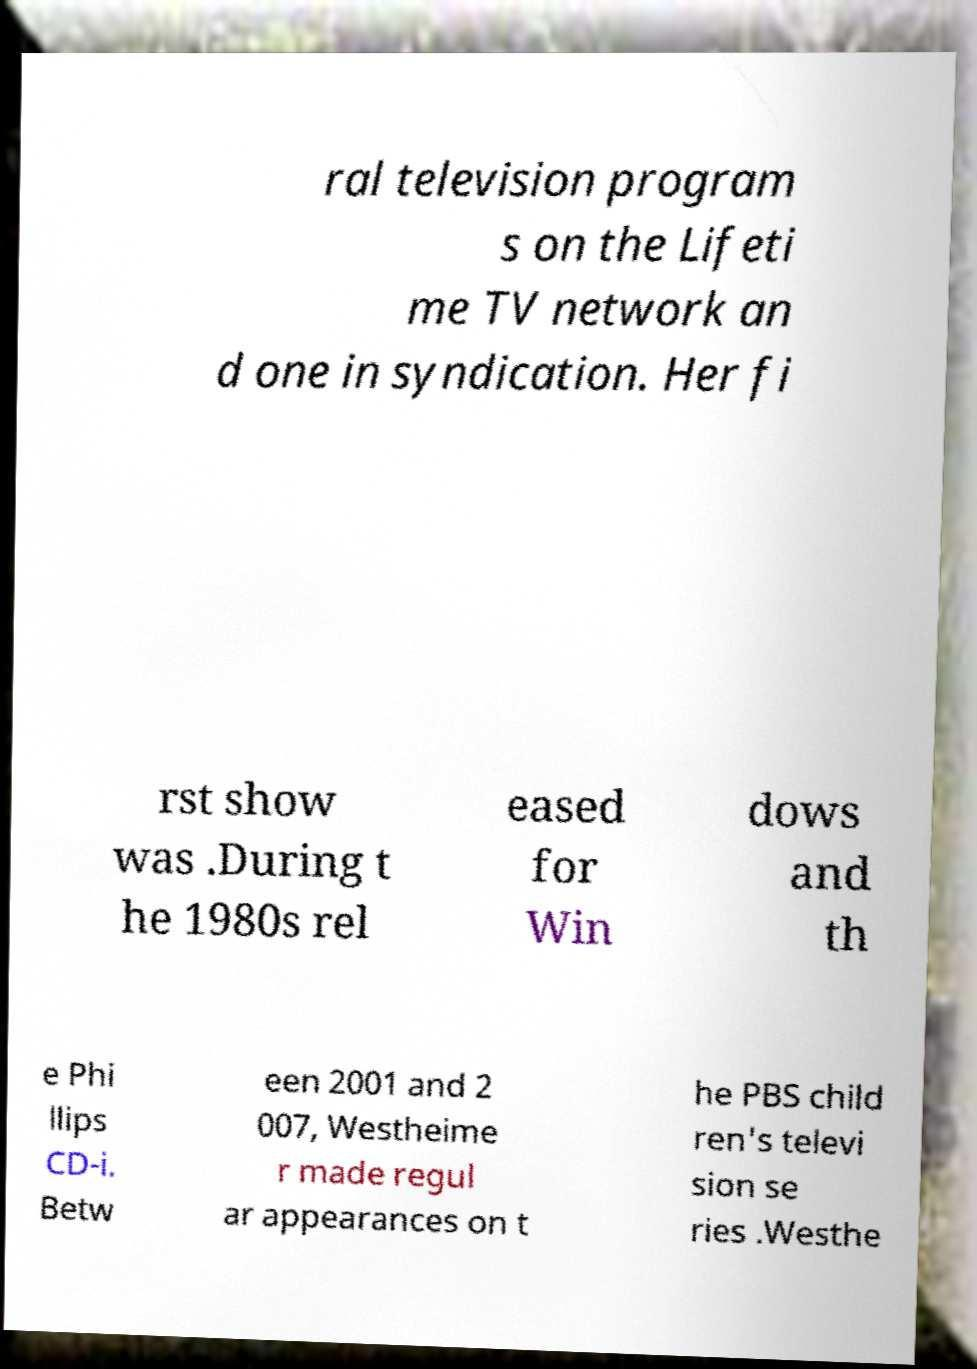What messages or text are displayed in this image? I need them in a readable, typed format. ral television program s on the Lifeti me TV network an d one in syndication. Her fi rst show was .During t he 1980s rel eased for Win dows and th e Phi llips CD-i. Betw een 2001 and 2 007, Westheime r made regul ar appearances on t he PBS child ren's televi sion se ries .Westhe 